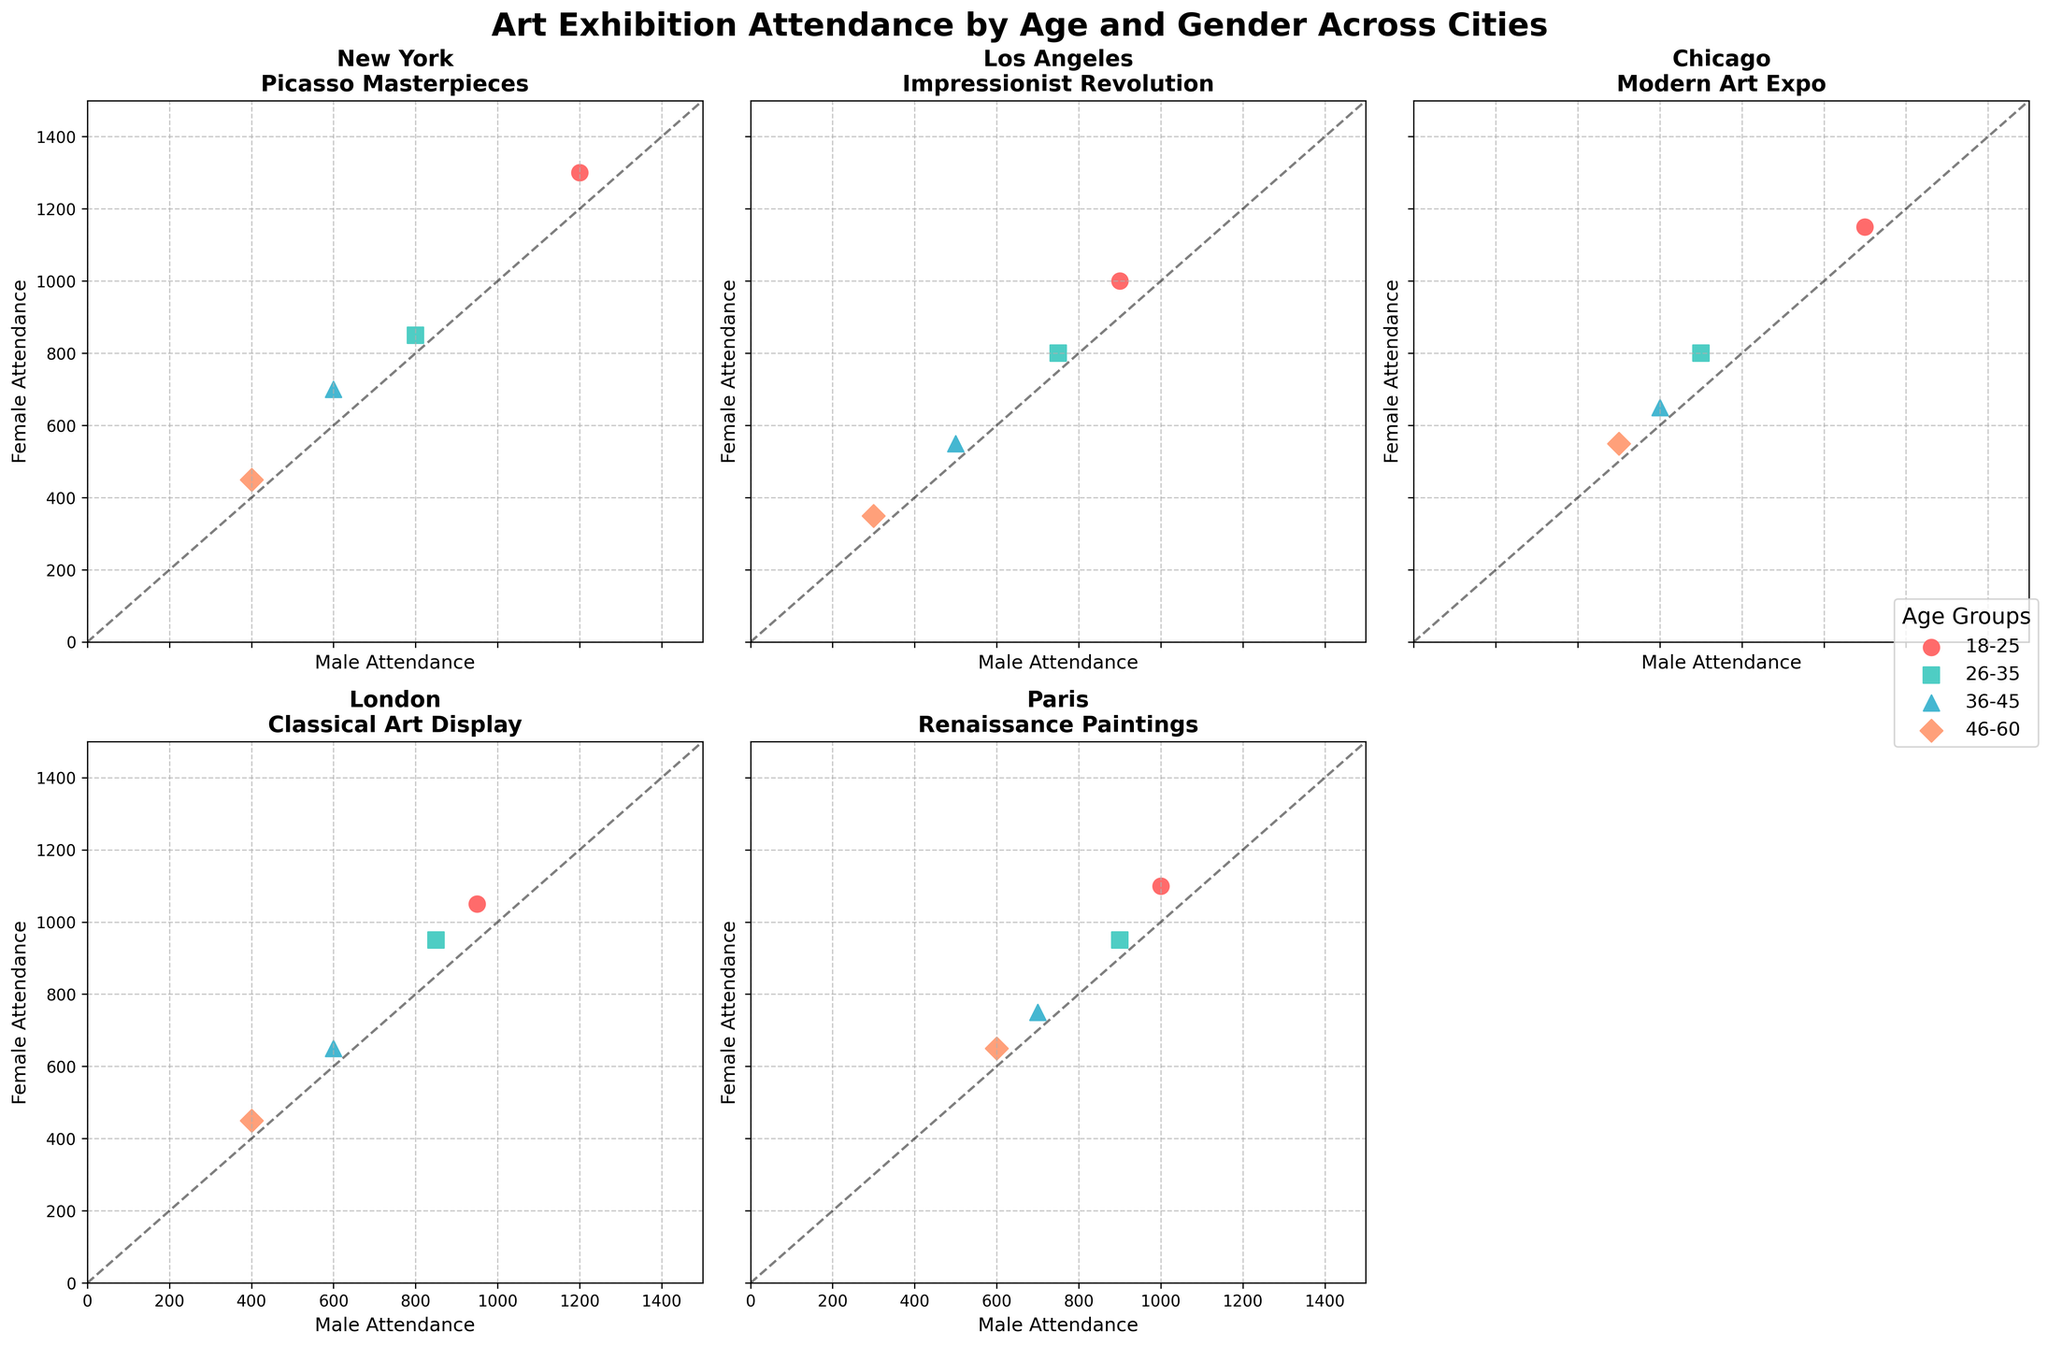Which city had the highest male attendance for the 18-25 age group? Look at the scatter plots and identify the city with the highest y-axis value for the 18-25 age group's male attendance.
Answer: New York How does female attendance compare between the 18-25 and 46-60 age groups in Los Angeles? In Los Angeles, compare the y-values for female attendance in the 18-25 age group (1000) and the 46-60 age group (350).
Answer: 18-25 age group has higher attendance Which city shows the most balanced male and female attendance for the 26-35 age group? Look for the city where the scatter point for age group 26-35 is closest to the diagonal line indicating equal male and female attendance.
Answer: Paris What is the difference in female attendance between the 26-35 and 36-45 age groups in Paris? Subtract the y-value of the 36-45 age group's female attendance (750) from that of the 26-35 age group (950).
Answer: 200 In which age group is there a higher variance in male attendance across all cities? Compare the spread of the x-values (male attendance) for each age group across all subplots.
Answer: 18-25 Which city's exhibition shows a larger draw for females compared to males in the 36-45 age group? Identify the subplot where the point for the 36-45 age group is higher on the y-axis than on the x-axis, indicating higher female attendance.
Answer: Chicago Are any cities showing a clear difference in exhibition attendance patterns between genders? Look for scatter points that consistently appear to be above or below the diagonal line across all age groups in any particular city's subplot.
Answer: Yes, multiple cities show this pattern How does attendance in Chicago's 'Modern Art Expo' differ between males and females aged 46-60? Identify the scatter point for the 46-60 age group in Chicago and compare its position on the x-axis (500 for males) and y-axis (550 for females).
Answer: Females have higher attendance Comparing London and Paris, which city has higher male attendance for the 18-25 age group? Compare the x-values for the 18-25 age group scatter points between London and Paris.
Answer: Chicago Does New York have more balanced gender attendance in the 36-45 age group compared to Los Angeles? Compare the scatter points for the 36-45 age group in both cities; the closer they are to the diagonal line, the more balanced the attendance.
Answer: New York 